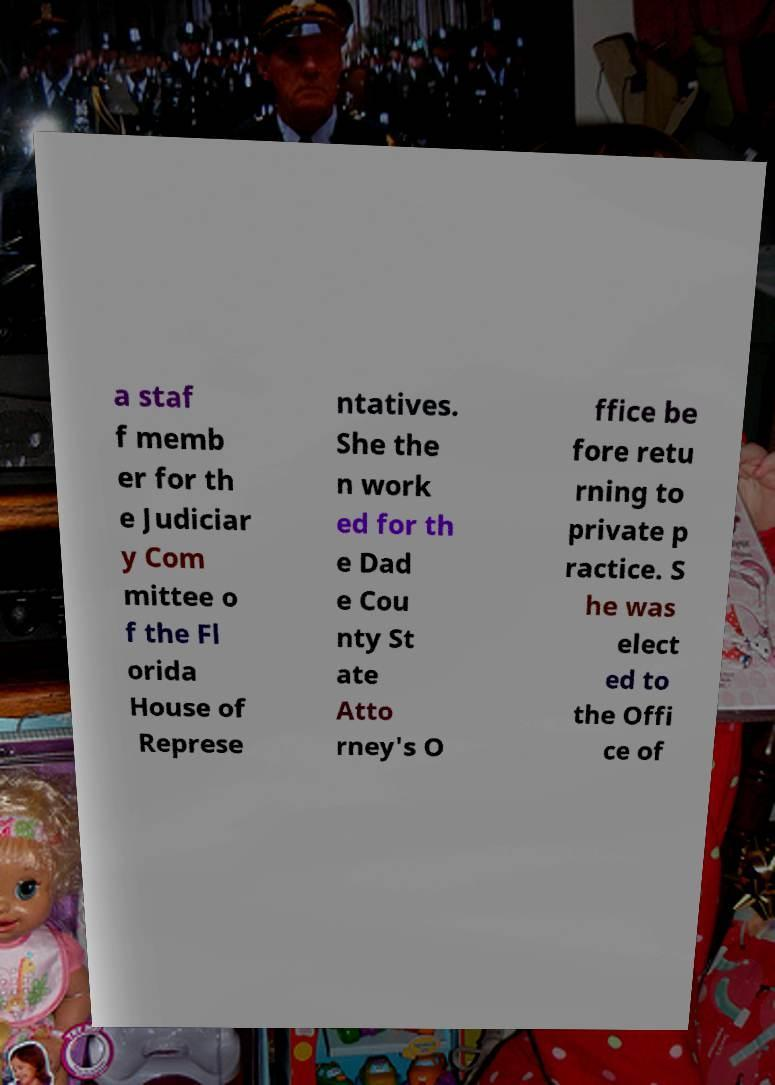Please read and relay the text visible in this image. What does it say? a staf f memb er for th e Judiciar y Com mittee o f the Fl orida House of Represe ntatives. She the n work ed for th e Dad e Cou nty St ate Atto rney's O ffice be fore retu rning to private p ractice. S he was elect ed to the Offi ce of 